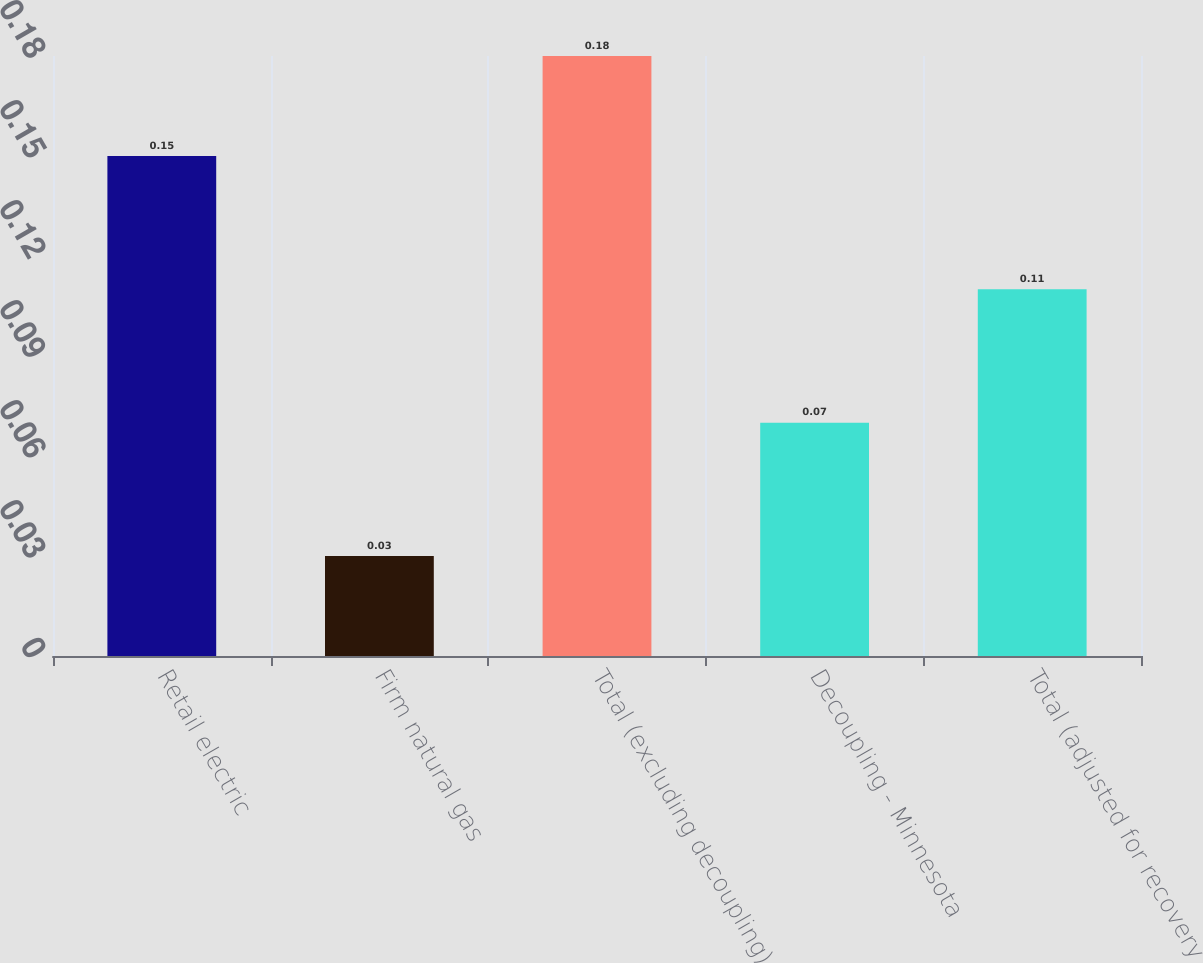Convert chart. <chart><loc_0><loc_0><loc_500><loc_500><bar_chart><fcel>Retail electric<fcel>Firm natural gas<fcel>Total (excluding decoupling)<fcel>Decoupling - Minnesota<fcel>Total (adjusted for recovery<nl><fcel>0.15<fcel>0.03<fcel>0.18<fcel>0.07<fcel>0.11<nl></chart> 